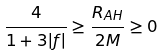Convert formula to latex. <formula><loc_0><loc_0><loc_500><loc_500>\frac { 4 } { 1 + 3 | f | } \geq \frac { R _ { A H } } { 2 M } \geq 0</formula> 